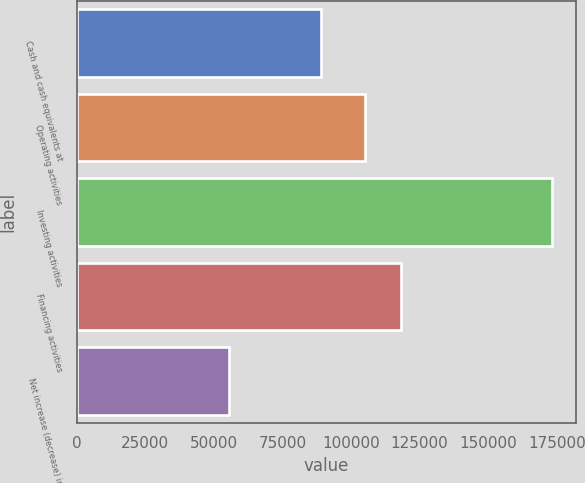Convert chart. <chart><loc_0><loc_0><loc_500><loc_500><bar_chart><fcel>Cash and cash equivalents at<fcel>Operating activities<fcel>Investing activities<fcel>Financing activities<fcel>Net increase (decrease) in<nl><fcel>88876<fcel>105068<fcel>173460<fcel>118175<fcel>55496.1<nl></chart> 